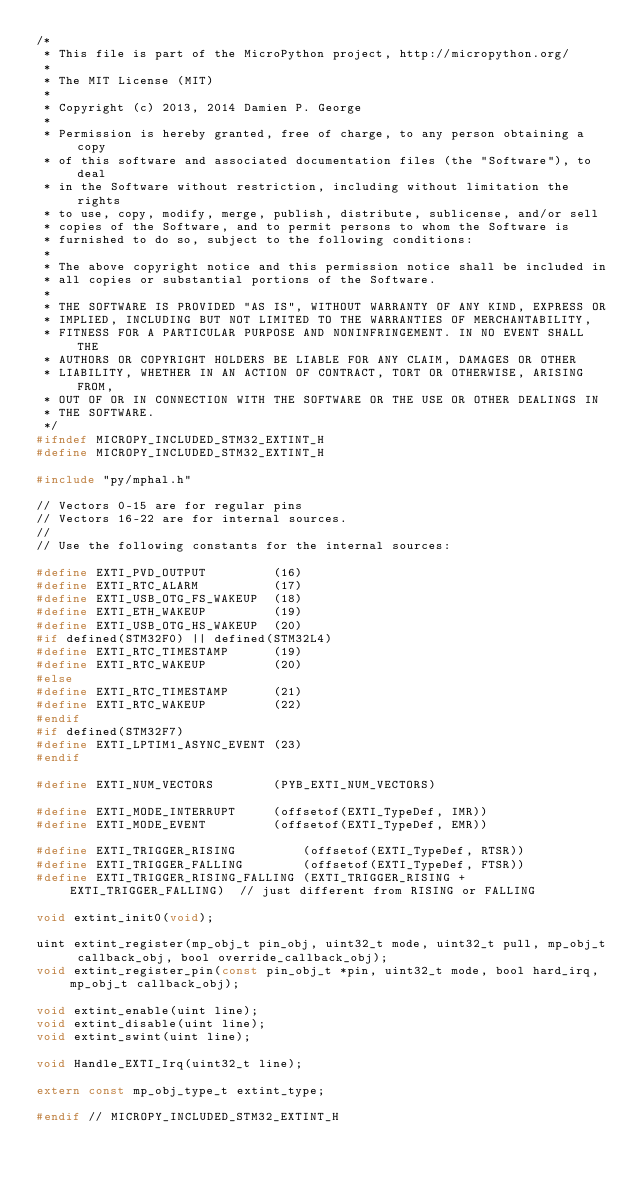<code> <loc_0><loc_0><loc_500><loc_500><_C_>/*
 * This file is part of the MicroPython project, http://micropython.org/
 *
 * The MIT License (MIT)
 *
 * Copyright (c) 2013, 2014 Damien P. George
 *
 * Permission is hereby granted, free of charge, to any person obtaining a copy
 * of this software and associated documentation files (the "Software"), to deal
 * in the Software without restriction, including without limitation the rights
 * to use, copy, modify, merge, publish, distribute, sublicense, and/or sell
 * copies of the Software, and to permit persons to whom the Software is
 * furnished to do so, subject to the following conditions:
 *
 * The above copyright notice and this permission notice shall be included in
 * all copies or substantial portions of the Software.
 *
 * THE SOFTWARE IS PROVIDED "AS IS", WITHOUT WARRANTY OF ANY KIND, EXPRESS OR
 * IMPLIED, INCLUDING BUT NOT LIMITED TO THE WARRANTIES OF MERCHANTABILITY,
 * FITNESS FOR A PARTICULAR PURPOSE AND NONINFRINGEMENT. IN NO EVENT SHALL THE
 * AUTHORS OR COPYRIGHT HOLDERS BE LIABLE FOR ANY CLAIM, DAMAGES OR OTHER
 * LIABILITY, WHETHER IN AN ACTION OF CONTRACT, TORT OR OTHERWISE, ARISING FROM,
 * OUT OF OR IN CONNECTION WITH THE SOFTWARE OR THE USE OR OTHER DEALINGS IN
 * THE SOFTWARE.
 */
#ifndef MICROPY_INCLUDED_STM32_EXTINT_H
#define MICROPY_INCLUDED_STM32_EXTINT_H

#include "py/mphal.h"

// Vectors 0-15 are for regular pins
// Vectors 16-22 are for internal sources.
//
// Use the following constants for the internal sources:

#define EXTI_PVD_OUTPUT         (16)
#define EXTI_RTC_ALARM          (17)
#define EXTI_USB_OTG_FS_WAKEUP  (18)
#define EXTI_ETH_WAKEUP         (19)
#define EXTI_USB_OTG_HS_WAKEUP  (20)
#if defined(STM32F0) || defined(STM32L4)
#define EXTI_RTC_TIMESTAMP      (19)
#define EXTI_RTC_WAKEUP         (20)
#else
#define EXTI_RTC_TIMESTAMP      (21)
#define EXTI_RTC_WAKEUP         (22)
#endif
#if defined(STM32F7)
#define EXTI_LPTIM1_ASYNC_EVENT (23)
#endif

#define EXTI_NUM_VECTORS        (PYB_EXTI_NUM_VECTORS)

#define EXTI_MODE_INTERRUPT     (offsetof(EXTI_TypeDef, IMR))
#define EXTI_MODE_EVENT         (offsetof(EXTI_TypeDef, EMR))

#define EXTI_TRIGGER_RISING         (offsetof(EXTI_TypeDef, RTSR))
#define EXTI_TRIGGER_FALLING        (offsetof(EXTI_TypeDef, FTSR))
#define EXTI_TRIGGER_RISING_FALLING (EXTI_TRIGGER_RISING + EXTI_TRIGGER_FALLING)  // just different from RISING or FALLING

void extint_init0(void);

uint extint_register(mp_obj_t pin_obj, uint32_t mode, uint32_t pull, mp_obj_t callback_obj, bool override_callback_obj);
void extint_register_pin(const pin_obj_t *pin, uint32_t mode, bool hard_irq, mp_obj_t callback_obj);

void extint_enable(uint line);
void extint_disable(uint line);
void extint_swint(uint line);

void Handle_EXTI_Irq(uint32_t line);

extern const mp_obj_type_t extint_type;

#endif // MICROPY_INCLUDED_STM32_EXTINT_H
</code> 